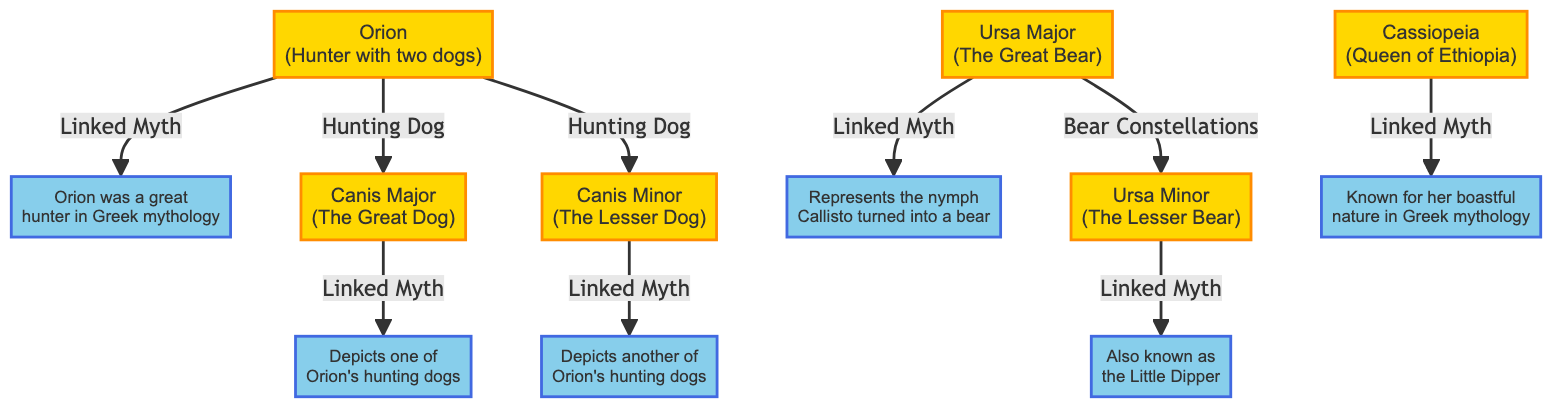What is the constellation associated with the hunting dog? The diagram shows that Canis Major and Canis Minor are linked as the hunting dogs of Orion. Therefore, Orion is the constellation associated with the hunting dogs.
Answer: Orion How many constellations are depicted in the diagram? Counting the nodes in the diagram, there are a total of 6 constellations: Orion, Canis Major, Canis Minor, Cassiopeia, Ursa Major, and Ursa Minor.
Answer: 6 What myth is associated with Cassiopeia? The diagram notes that Cassiopeia is known for her boastful nature in Greek mythology. Hence, this detail provides the myth linked directly to the constellation.
Answer: Known for her boastful nature in Greek mythology Which constellation is linked to Ursa Major as a bear constellation? The diagram indicates a connection between Ursa Major and Ursa Minor as bear constellations, meaning Ursa Minor is linked to Ursa Major in this context.
Answer: Ursa Minor What is the famous nickname of Ursa Minor? The diagram identifies Ursa Minor as "the Little Dipper," which is a well-known name often associated with this constellation.
Answer: the Little Dipper What relationship exists between Orion and Canis Major? According to the diagram, there is a direct connection labeled as "Hunting Dog" from Orion to Canis Major, indicating that Canis Major is one of the hunting dogs of Orion.
Answer: Hunting Dog What does the constellation Orion represent in Greek mythology? The information provided in the diagram states that Orion is depicted as a great hunter in Greek mythology, which summarizes its myth perfectly.
Answer: Orion was a great hunter in Greek mythology Which constellation is known as the Great Bear? The diagram specifies that Ursa Major is recognized as "The Great Bear," directly providing its name as per the traditional Greek and Roman nomenclature.
Answer: Ursa Major What connects Canis Major and Canis Minor? The diagram illustrates that both Canis Major and Canis Minor are hunting dogs connected directly to the constellation Orion, showcasing their relationship by depicting them as companions of the hunter.
Answer: Hunting Dog 